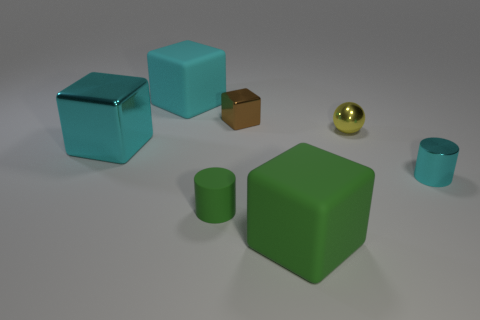Which objects in the image could fit inside each other, theoretically? If we're talking about fitting inside by size alone, the teal cup might fit inside the green cube, and the small brown box could fit inside the blue cube. The golden sphere does not have a cavity to fit another object inside it. 